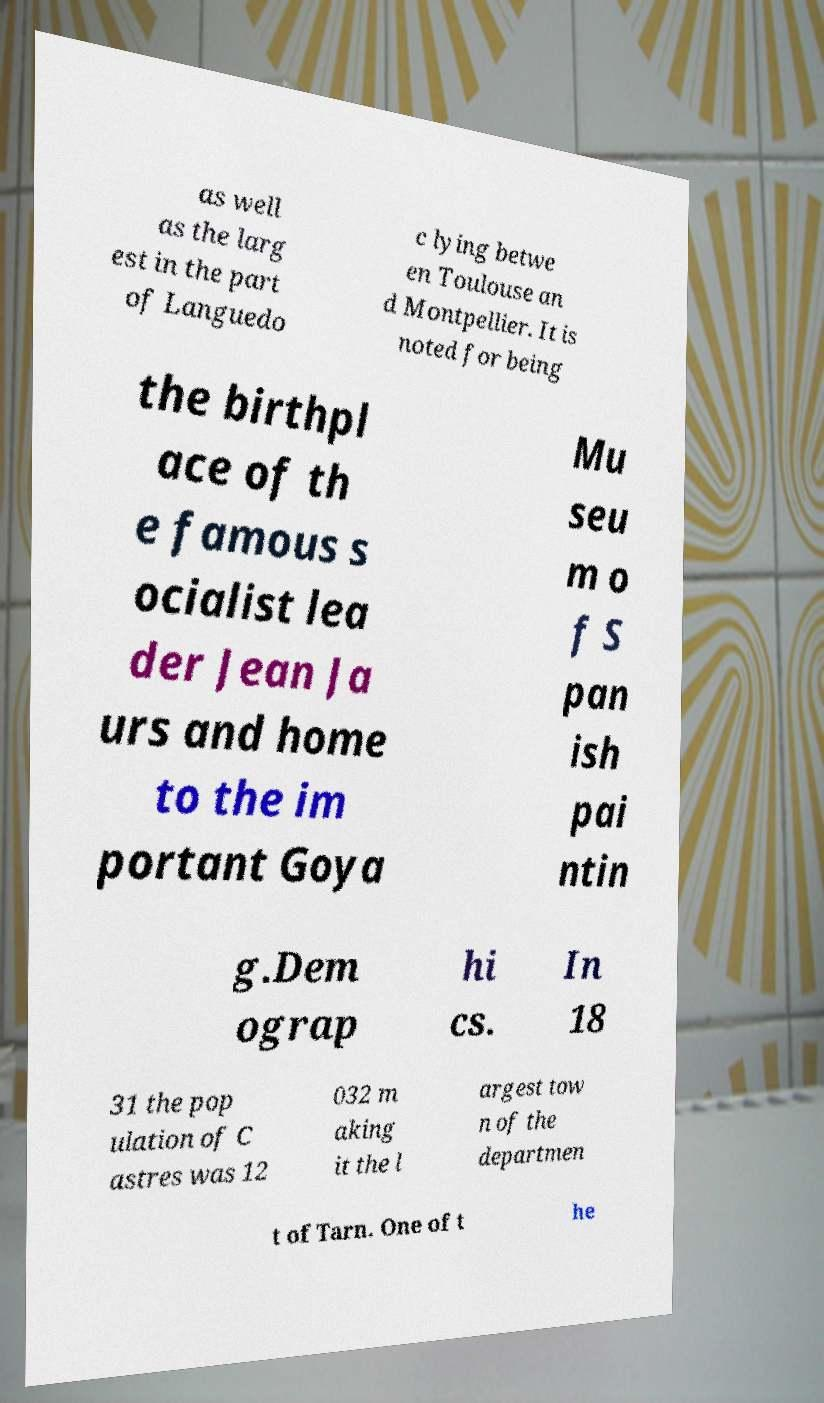For documentation purposes, I need the text within this image transcribed. Could you provide that? as well as the larg est in the part of Languedo c lying betwe en Toulouse an d Montpellier. It is noted for being the birthpl ace of th e famous s ocialist lea der Jean Ja urs and home to the im portant Goya Mu seu m o f S pan ish pai ntin g.Dem ograp hi cs. In 18 31 the pop ulation of C astres was 12 032 m aking it the l argest tow n of the departmen t of Tarn. One of t he 